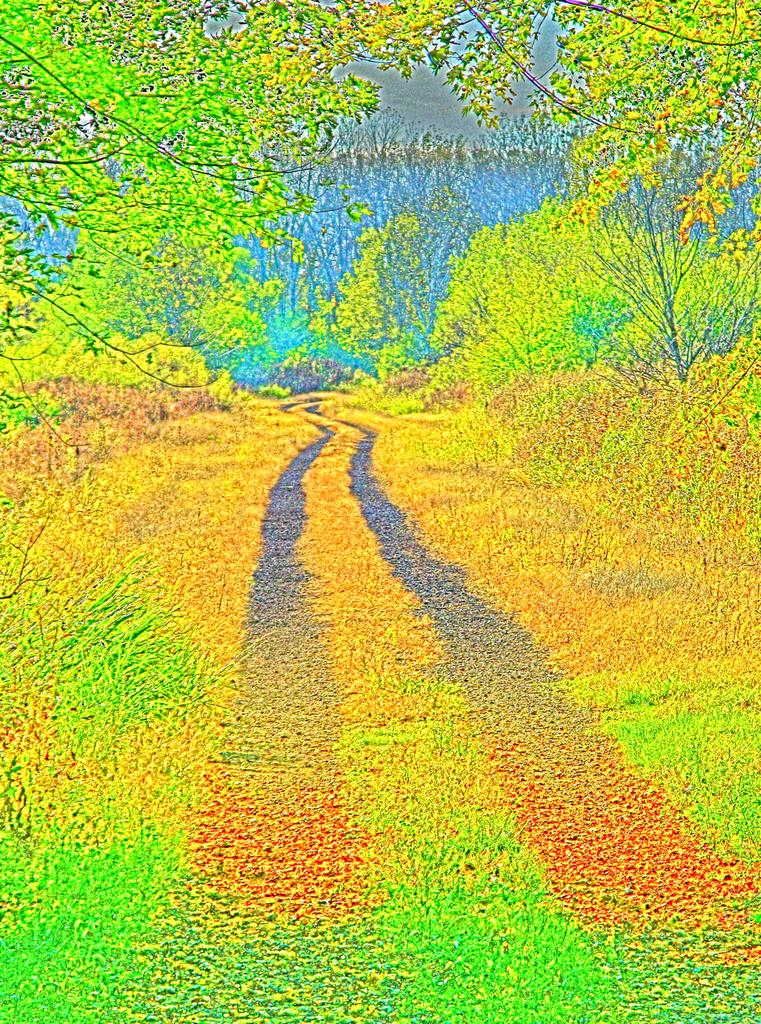What type of artwork is depicted in the image? The image is a painting. What is present on the surface in the image? There is grass on the surface in the image. What can be seen in the background of the painting? There are trees in the background of the image. What type of net is being used by the fireman in the image? There is no fireman or net present in the image; it is a painting with grass on the surface and trees in the background. 